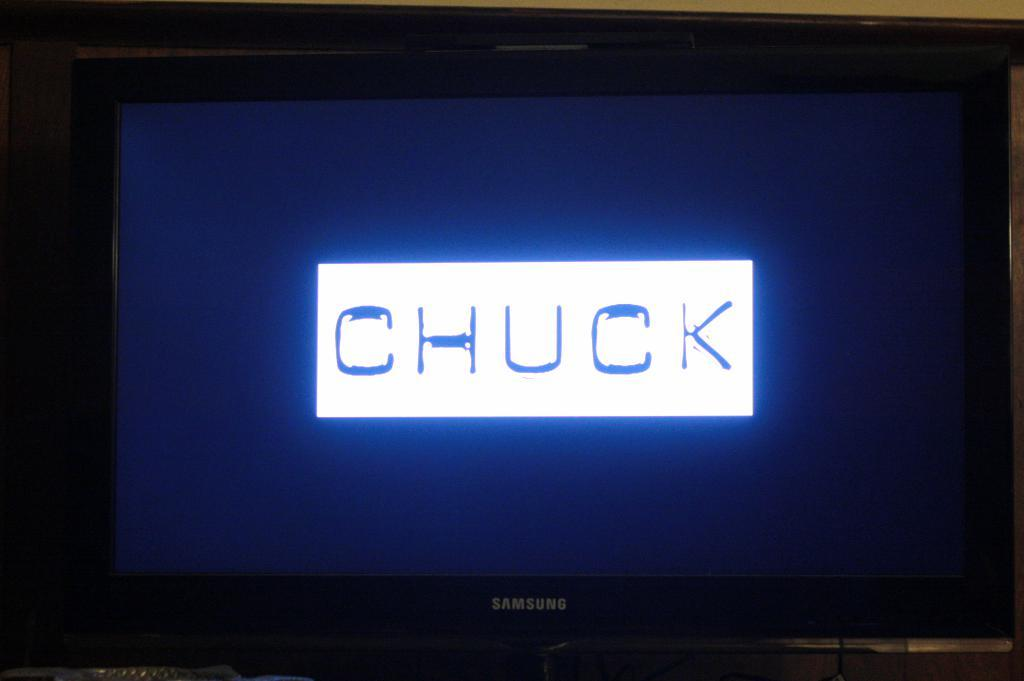<image>
Write a terse but informative summary of the picture. The screen of a samsung branded device that says chuck in the center. 